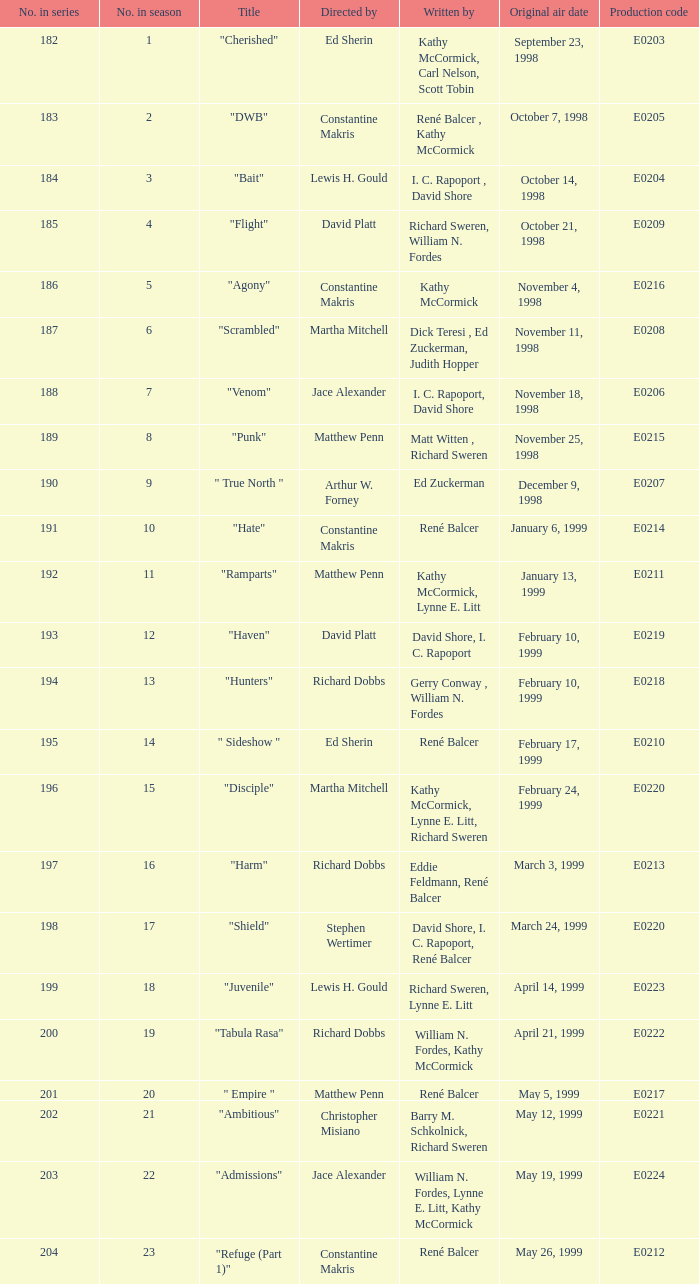Who is the author of the episode that originally aired on january 13, 1999? Kathy McCormick, Lynne E. Litt. 